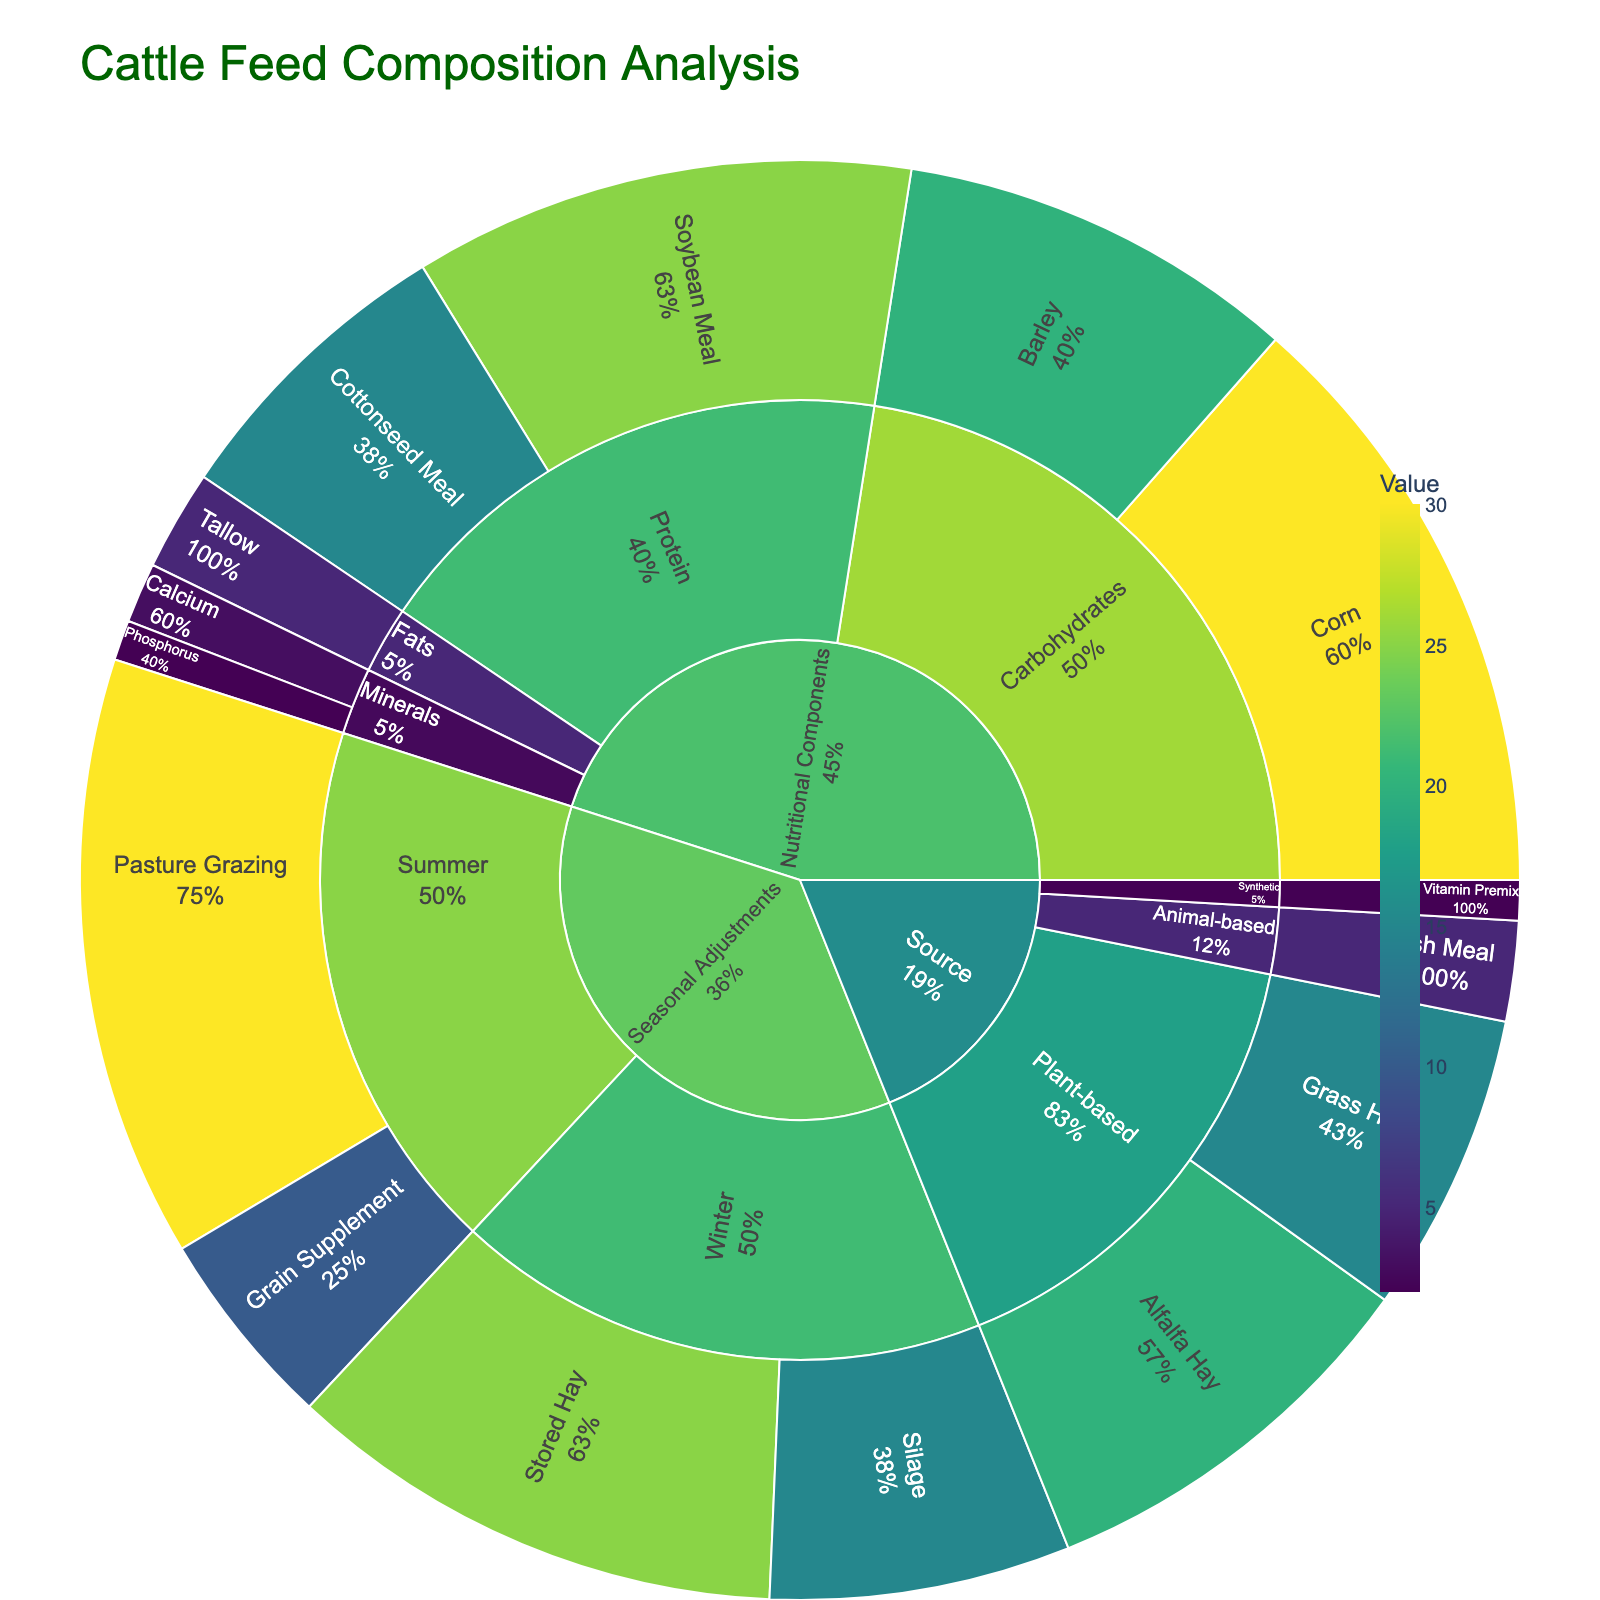What is the title of the figure? The title is clearly displayed at the top of the figure.
Answer: Cattle Feed Composition Analysis What is the value of Soybean Meal under Protein? Follow the path Nutritional Components -> Protein -> Soybean Meal in the sunburst plot and refer to the displayed value.
Answer: 25 Which feed component has the highest value under Carbohydrates? Navigate through Nutritional Components -> Carbohydrates and compare the values for Corn and Barley.
Answer: Corn What's the total value of animal-based and synthetic sources combined? Find values under Source -> Animal-based (Fish Meal: 5) and Source -> Synthetic (Vitamin Premix: 2). Sum them up: 5 + 2 = 7.
Answer: 7 Which subcategory under Nutritional Components contains the least value? Compare the sum of values for each subcategory (Protein: 25+15, Carbohydrates: 30+20, Fats: 5, Minerals: 3+2). The least sum is for Fats.
Answer: Fats How does the value of Tallow compare to that of Barley? Refer to the values under Nutritional Components -> Fats -> Tallow (5) and Nutritional Components -> Carbohydrates -> Barley (20). Tallow is less than Barley.
Answer: Less What is the sum of values for all items under Winter in Seasonal Adjustments? Sum the values under Seasonal Adjustments -> Winter (Stored Hay: 25, Silage: 15). Total is 25 + 15 = 40.
Answer: 40 Which is greater, the value of Pasture Grazing in Summer or the total value of Plant-based sources? Compare the value of Summer -> Pasture Grazing (30) with the sum of values for Plant-based sources under Source (Alfalfa Hay: 20, Grass Hay: 15). Summer -> Pasture Grazing (30) is greater than Plant-based total (35).
Answer: Plant-based sources total What percentage of the total value does Corn contribute under Nutritional Components? Calculate the percentage: (Corn's value / Total value under Nutritional Components) * 100. Total under Nutritional Components is 100 (sum of all categories), Corn's value is 30. Hence: (30/100) * 100 = 30%.
Answer: 30% During which season is the feed component value for pasture grazing higher? Compare values for Pasture Grazing under Seasonal Adjustments -> Summer (30) and Winter (not listed, implying 0). Summer has the higher value.
Answer: Summer 